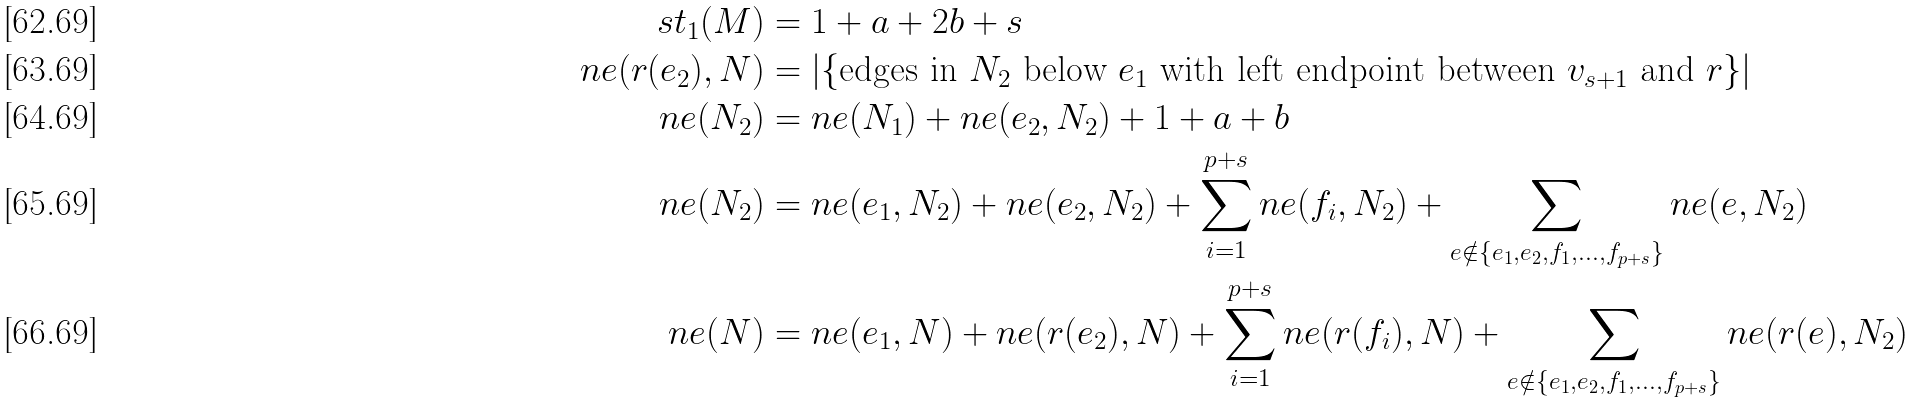Convert formula to latex. <formula><loc_0><loc_0><loc_500><loc_500>s t _ { 1 } ( M ) & = 1 + a + 2 b + s \\ n e ( r ( e _ { 2 } ) , N ) & = \left | \{ \text {edges in $N_{2}$ below $e_{1}$ with left endpoint between $v_{s+1}$ and $r$} \} \right | \\ n e ( N _ { 2 } ) & = n e ( N _ { 1 } ) + n e ( e _ { 2 } , N _ { 2 } ) + 1 + a + b \\ n e ( N _ { 2 } ) & = n e ( e _ { 1 } , N _ { 2 } ) + n e ( e _ { 2 } , N _ { 2 } ) + \sum _ { i = 1 } ^ { p + s } { n e ( f _ { i } , N _ { 2 } ) } + \sum _ { e \notin \{ e _ { 1 } , e _ { 2 } , f _ { 1 } , \dots , f _ { p + s } \} } { n e ( e , N _ { 2 } ) } \\ n e ( N ) & = n e ( e _ { 1 } , N ) + n e ( r ( e _ { 2 } ) , N ) + \sum _ { i = 1 } ^ { p + s } { n e ( r ( f _ { i } ) , N ) } + \sum _ { e \notin \{ e _ { 1 } , e _ { 2 } , f _ { 1 } , \dots , f _ { p + s } \} } { n e ( r ( e ) , N _ { 2 } ) }</formula> 